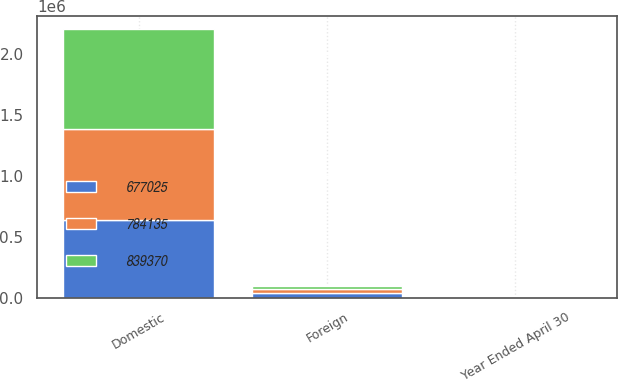<chart> <loc_0><loc_0><loc_500><loc_500><stacked_bar_chart><ecel><fcel>Year Ended April 30<fcel>Domestic<fcel>Foreign<nl><fcel>677025<fcel>2011<fcel>639914<fcel>37111<nl><fcel>784135<fcel>2010<fcel>745912<fcel>38223<nl><fcel>839370<fcel>2009<fcel>815614<fcel>23756<nl></chart> 